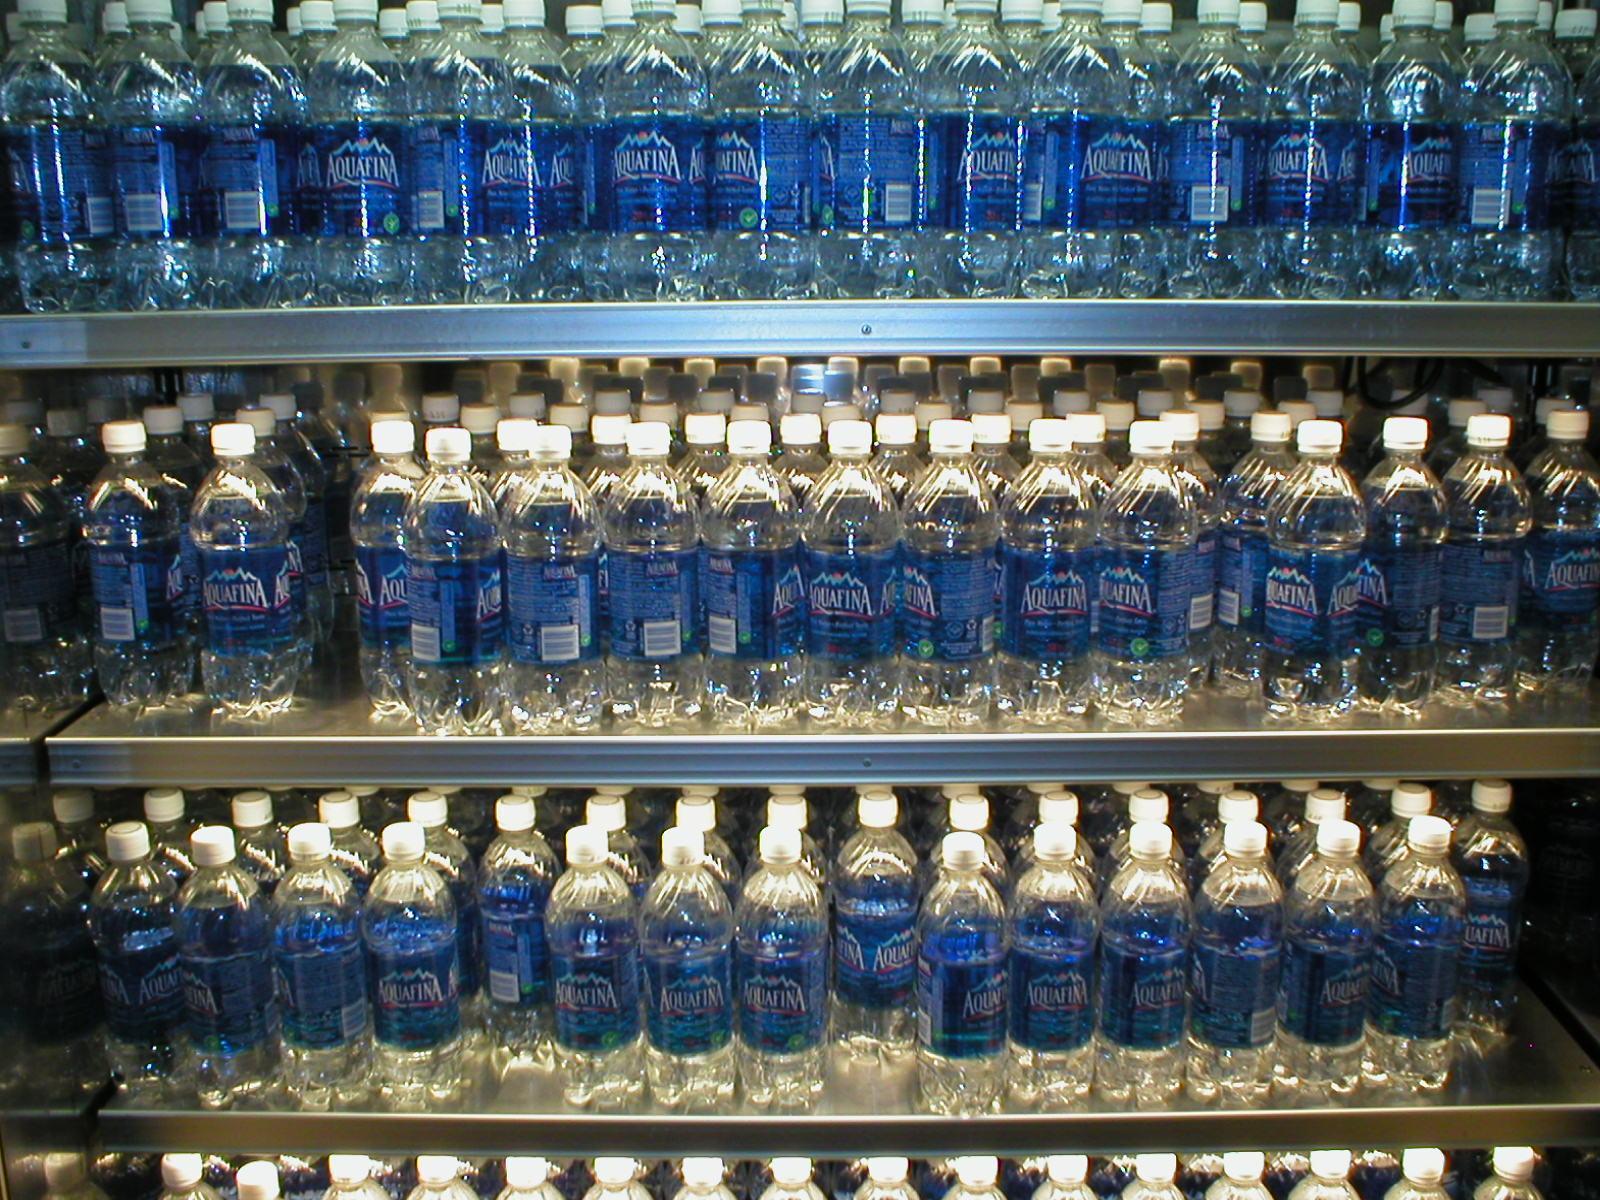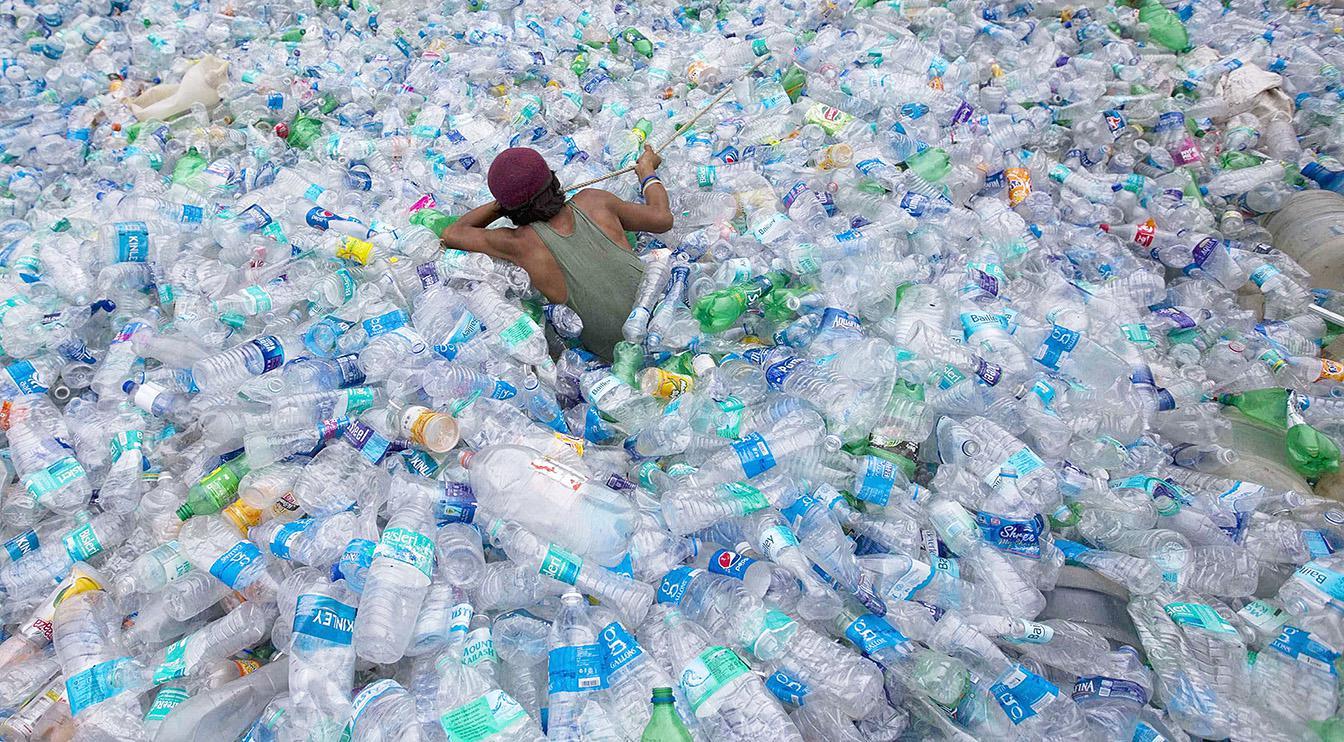The first image is the image on the left, the second image is the image on the right. Given the left and right images, does the statement "At least one image contains small water bottles arranged in neat rows." hold true? Answer yes or no. Yes. The first image is the image on the left, the second image is the image on the right. Analyze the images presented: Is the assertion "One image shows water bottles in multiple tiers." valid? Answer yes or no. Yes. 